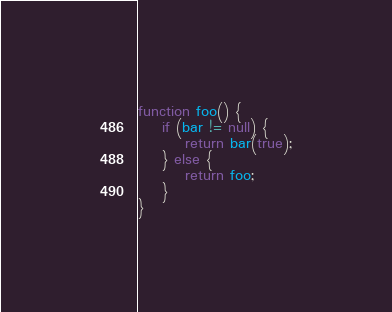Convert code to text. <code><loc_0><loc_0><loc_500><loc_500><_JavaScript_>function foo() {
	if (bar != null) {
		return bar(true);
	} else {
		return foo;
	}
}
</code> 